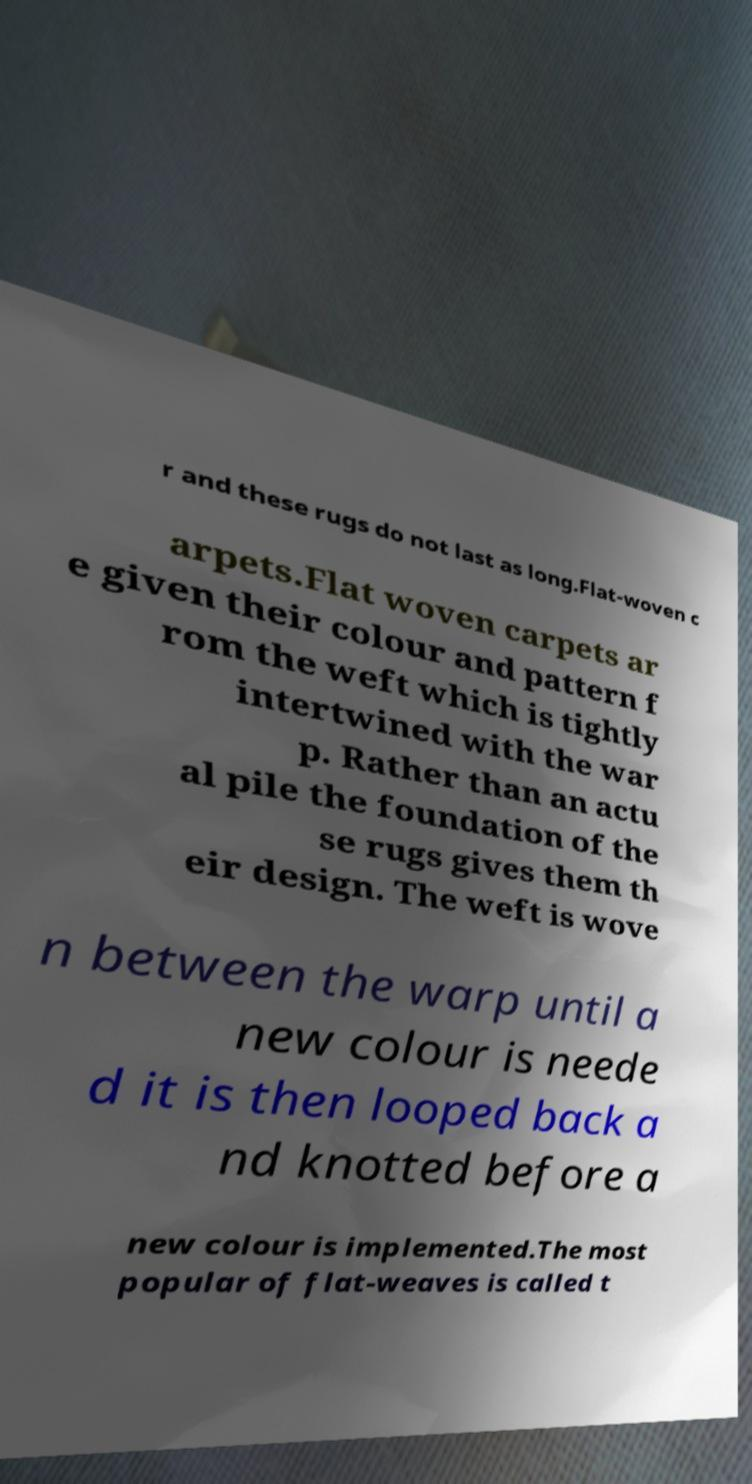Please read and relay the text visible in this image. What does it say? r and these rugs do not last as long.Flat-woven c arpets.Flat woven carpets ar e given their colour and pattern f rom the weft which is tightly intertwined with the war p. Rather than an actu al pile the foundation of the se rugs gives them th eir design. The weft is wove n between the warp until a new colour is neede d it is then looped back a nd knotted before a new colour is implemented.The most popular of flat-weaves is called t 